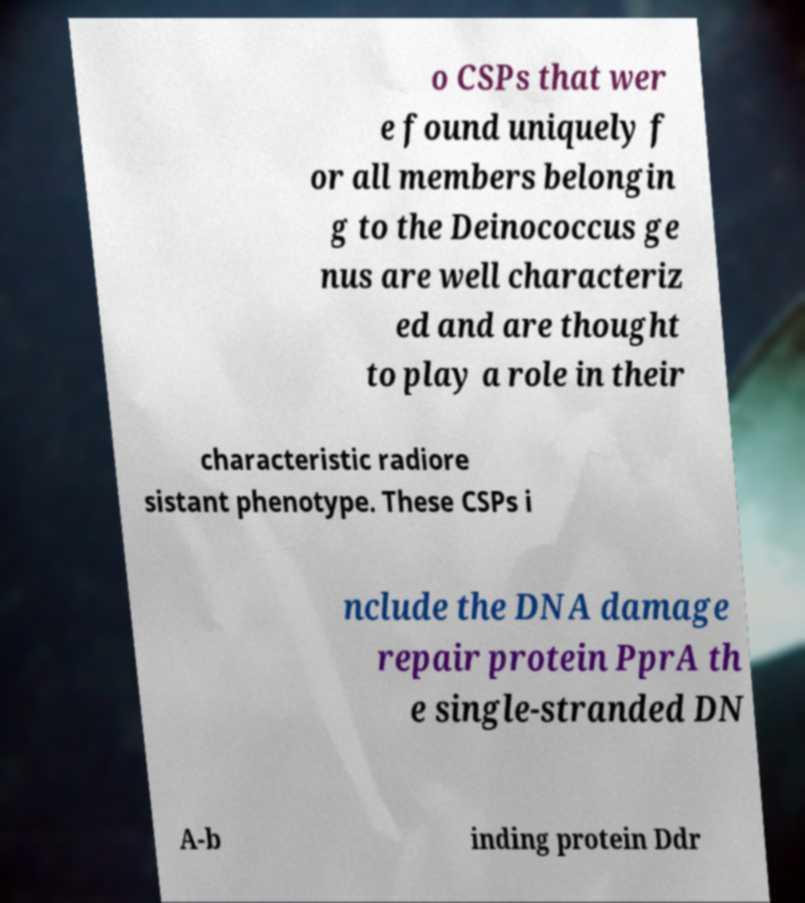I need the written content from this picture converted into text. Can you do that? o CSPs that wer e found uniquely f or all members belongin g to the Deinococcus ge nus are well characteriz ed and are thought to play a role in their characteristic radiore sistant phenotype. These CSPs i nclude the DNA damage repair protein PprA th e single-stranded DN A-b inding protein Ddr 